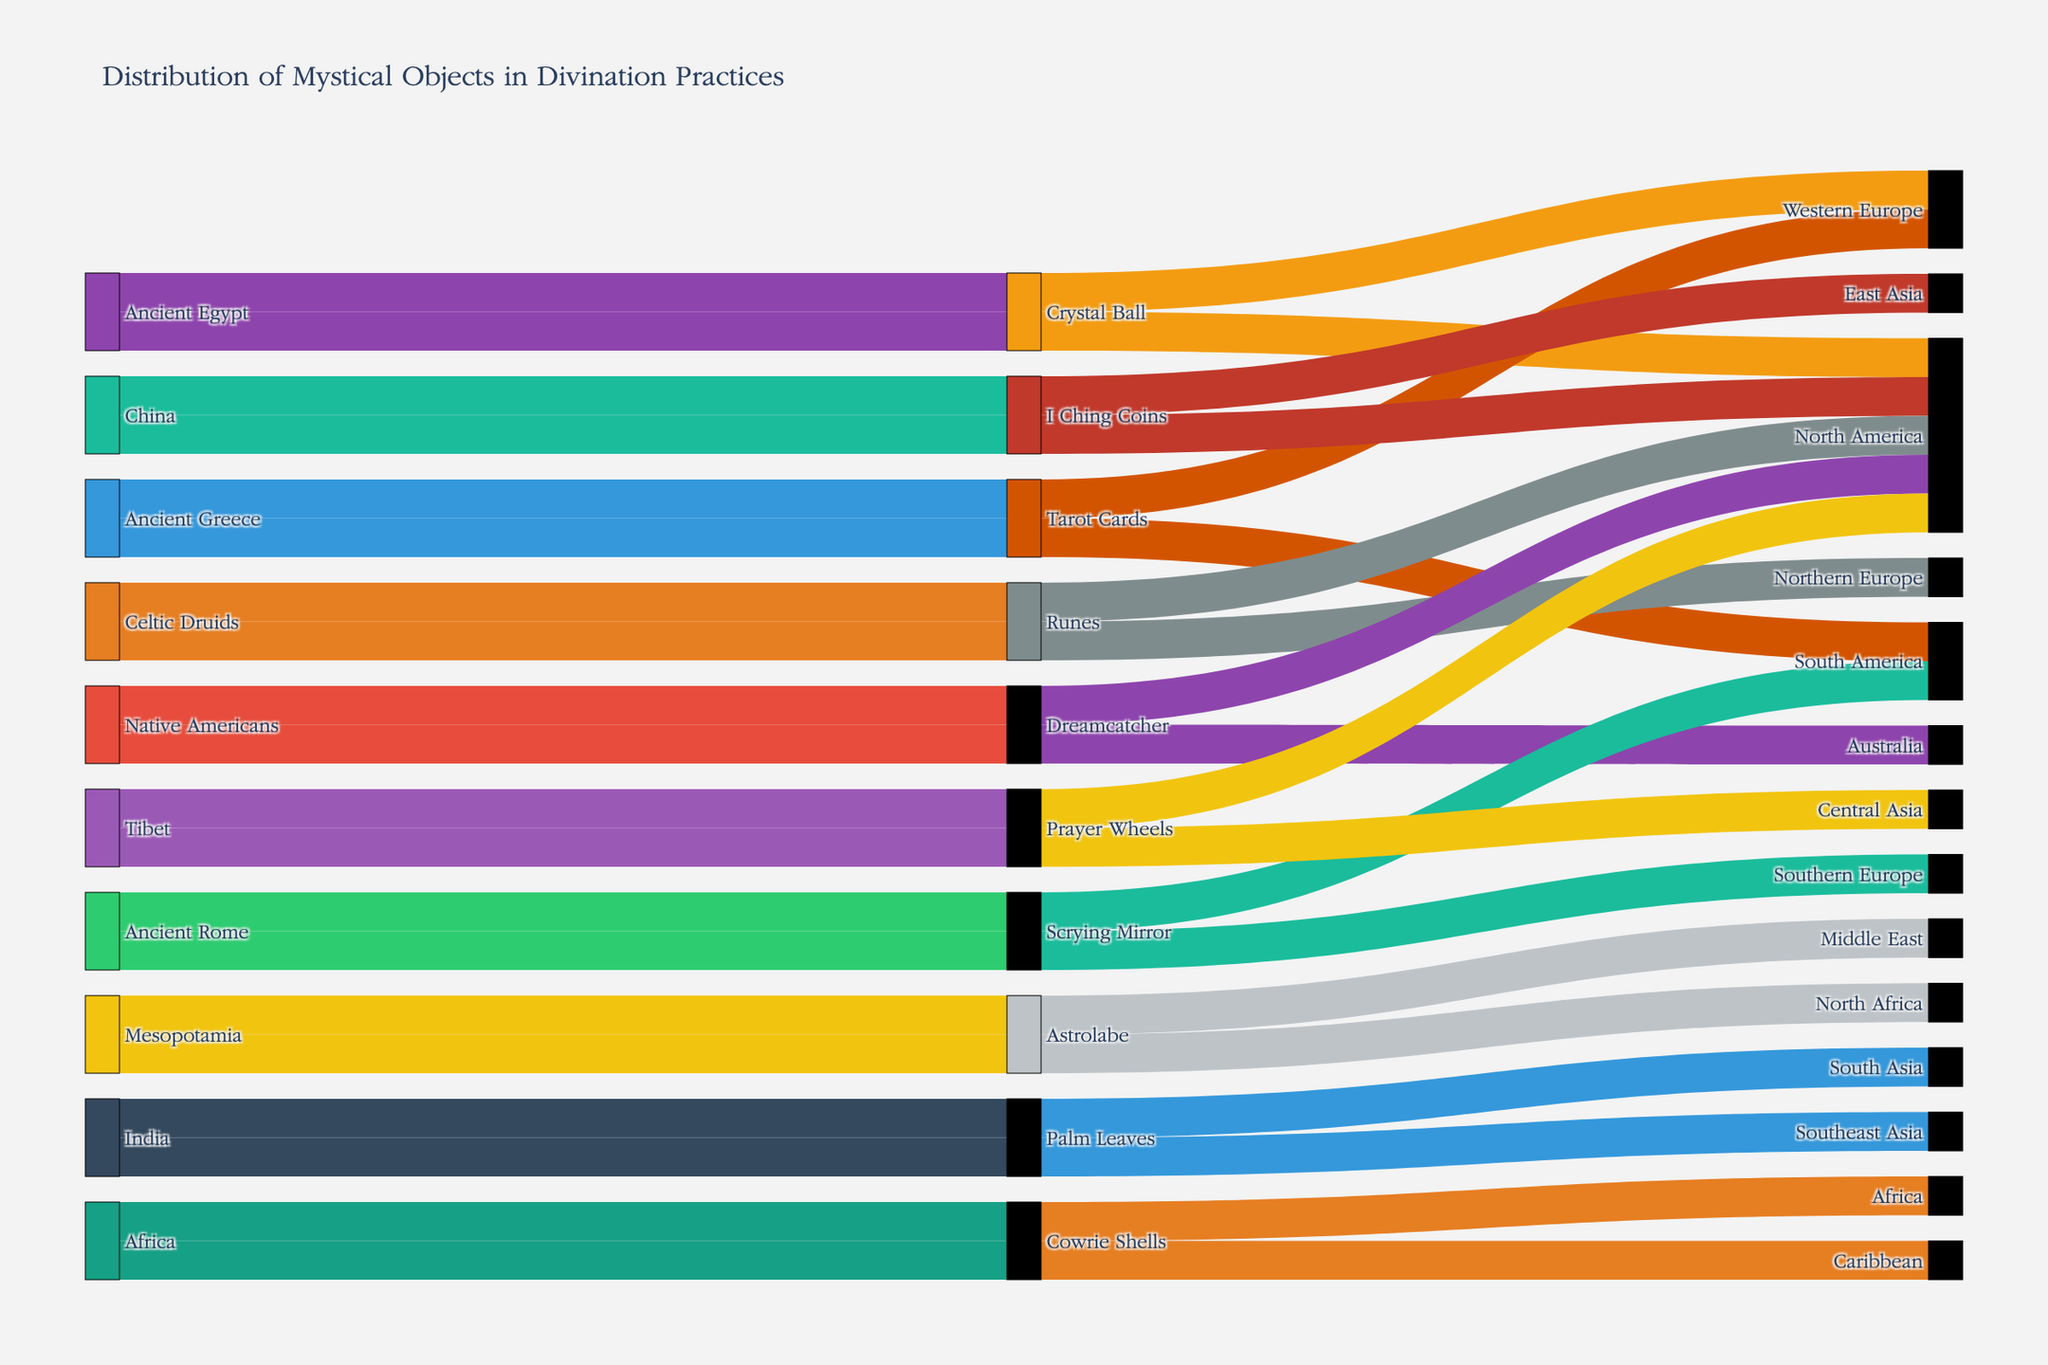What's the primary origin of Crystal Balls? By looking at the Sankey Diagram, trace the flow from sources to the object "Crystal Ball". The primary origin is the source with the most paths leading to "Crystal Ball".
Answer: Ancient Egypt How many types of mystical objects are used by North American fortune tellers? Identify the paths leading to "North America" as the destination. Count the unique objects associated with these paths.
Answer: Six Which destination receives mystical objects from the most varied origins? Count the number of unique sources for each destination. The destination with the highest count has the most varied origins.
Answer: North America What is the relationship between Ancient Greece and Tarot Cards in terms of destination distribution? Examine the paths from "Ancient Greece" to "Tarot Cards" and check where they further lead. Identify the destinations and compare.
Answer: Western Europe and South America Compare the distribution of objects originating from India and Tibet. Identify the paths originating from "India" and "Tibet", then compare the destinations each source leads to.
Answer: India objects go to South Asia and Southeast Asia, while Tibet objects go to Central Asia and North America Which origin has the most diverse mystical objects? Count the number of different mystical objects originating from each source. The origin with the highest count has the most diverse objects.
Answer: China, Ancient Egypt, Ancient Greece, Mesopotamia, Celtic Druids, Native Americans, India, Ancient Rome, Tibet, Africa (One object each) Where are the Cowrie Shells currently used? Follow the paths from the object "Cowrie Shells" to its destinations. Identify the end points.
Answer: Africa, Caribbean How many mystical objects from the Ancient Rome have spread to South America? Trace the specific paths from "Ancient Rome" to "South America" and count the objects.
Answer: One Identify the distinctive color used for the object "Prayer Wheels". Find the path corresponding to "Prayer Wheels" and note its color, which should follow a consistent color scheme.
Answer: Blue (assuming a specific color, verify with diagram) What are the common destinations for mystical objects from China and Mesopotamia? Check the destinations for mystical objects originating from "China" and "Mesopotamia" and identify any shared destinations.
Answer: None 